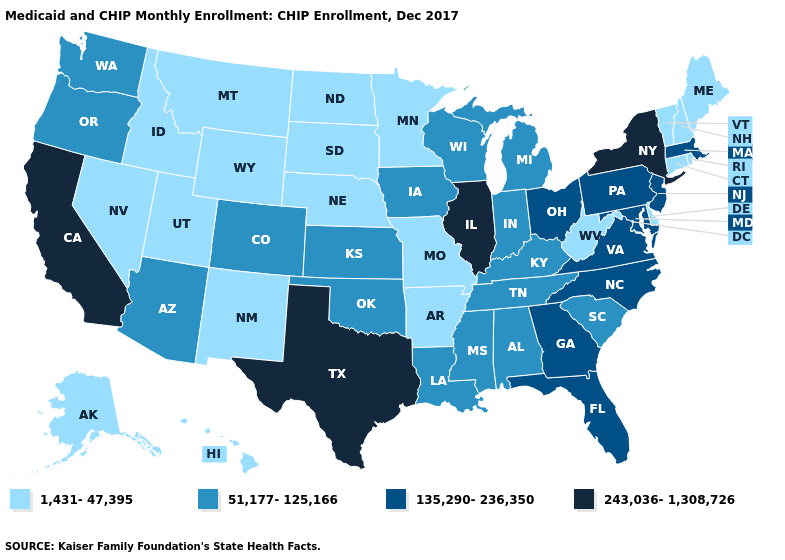Name the states that have a value in the range 1,431-47,395?
Concise answer only. Alaska, Arkansas, Connecticut, Delaware, Hawaii, Idaho, Maine, Minnesota, Missouri, Montana, Nebraska, Nevada, New Hampshire, New Mexico, North Dakota, Rhode Island, South Dakota, Utah, Vermont, West Virginia, Wyoming. Does Missouri have the lowest value in the USA?
Quick response, please. Yes. Does the map have missing data?
Concise answer only. No. What is the highest value in the USA?
Keep it brief. 243,036-1,308,726. Which states have the lowest value in the USA?
Short answer required. Alaska, Arkansas, Connecticut, Delaware, Hawaii, Idaho, Maine, Minnesota, Missouri, Montana, Nebraska, Nevada, New Hampshire, New Mexico, North Dakota, Rhode Island, South Dakota, Utah, Vermont, West Virginia, Wyoming. Does Kentucky have a lower value than Delaware?
Answer briefly. No. Name the states that have a value in the range 243,036-1,308,726?
Answer briefly. California, Illinois, New York, Texas. Which states have the lowest value in the USA?
Keep it brief. Alaska, Arkansas, Connecticut, Delaware, Hawaii, Idaho, Maine, Minnesota, Missouri, Montana, Nebraska, Nevada, New Hampshire, New Mexico, North Dakota, Rhode Island, South Dakota, Utah, Vermont, West Virginia, Wyoming. Name the states that have a value in the range 243,036-1,308,726?
Give a very brief answer. California, Illinois, New York, Texas. What is the value of Vermont?
Concise answer only. 1,431-47,395. Does the map have missing data?
Write a very short answer. No. Does Connecticut have a lower value than Virginia?
Give a very brief answer. Yes. What is the value of South Dakota?
Answer briefly. 1,431-47,395. Which states have the lowest value in the MidWest?
Answer briefly. Minnesota, Missouri, Nebraska, North Dakota, South Dakota. What is the value of South Dakota?
Give a very brief answer. 1,431-47,395. 